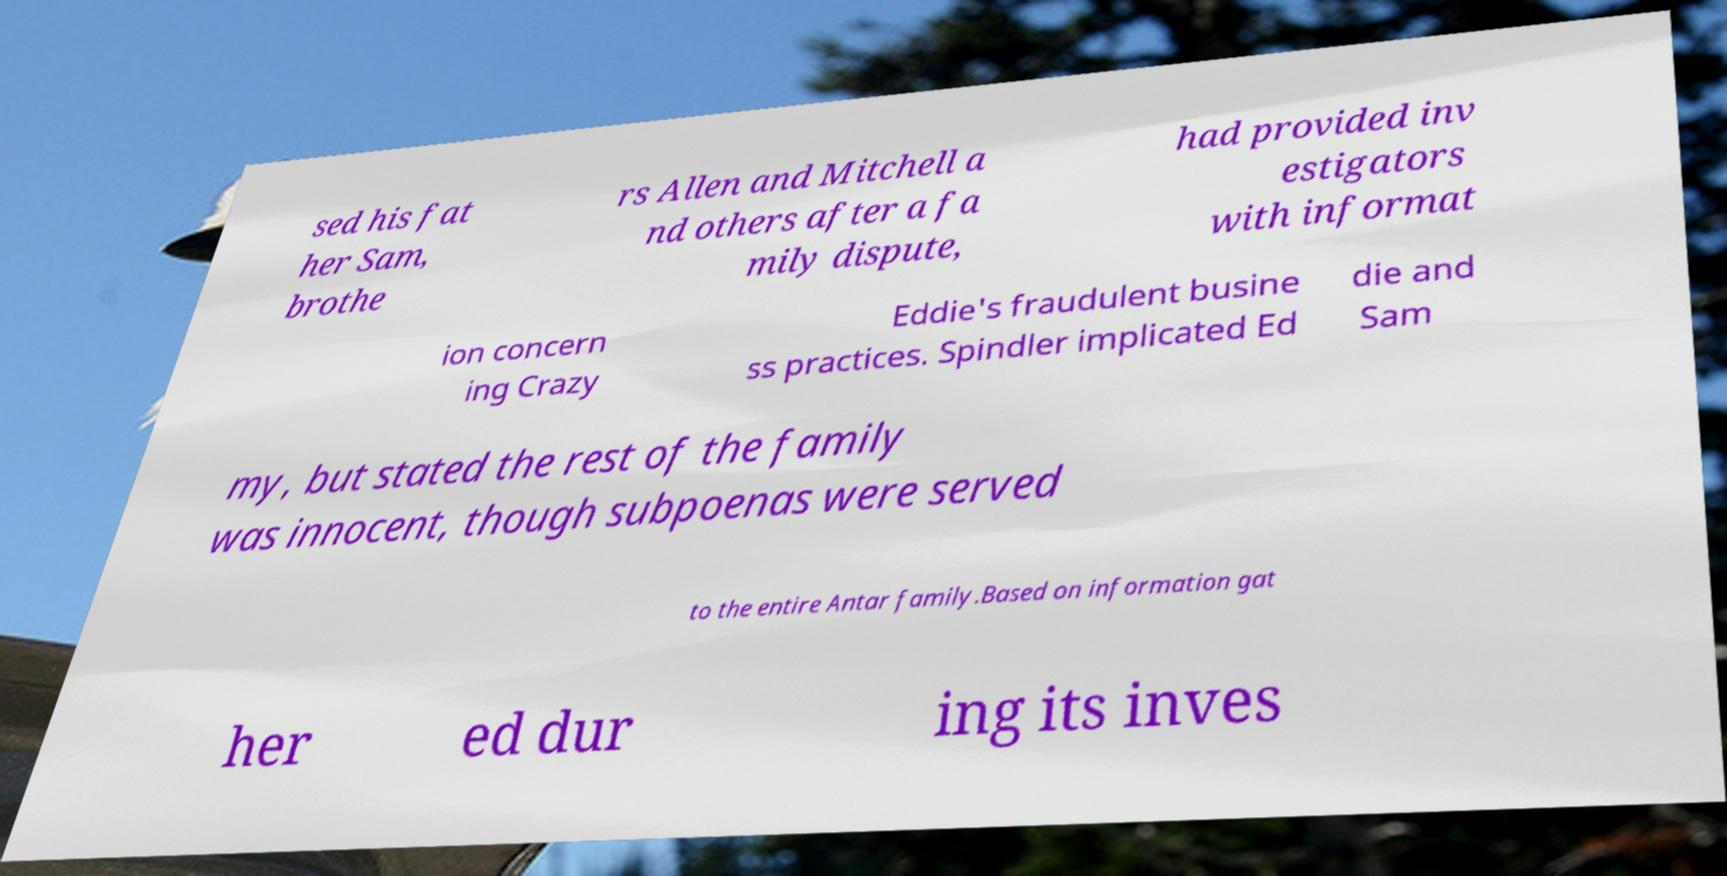Could you extract and type out the text from this image? sed his fat her Sam, brothe rs Allen and Mitchell a nd others after a fa mily dispute, had provided inv estigators with informat ion concern ing Crazy Eddie's fraudulent busine ss practices. Spindler implicated Ed die and Sam my, but stated the rest of the family was innocent, though subpoenas were served to the entire Antar family.Based on information gat her ed dur ing its inves 